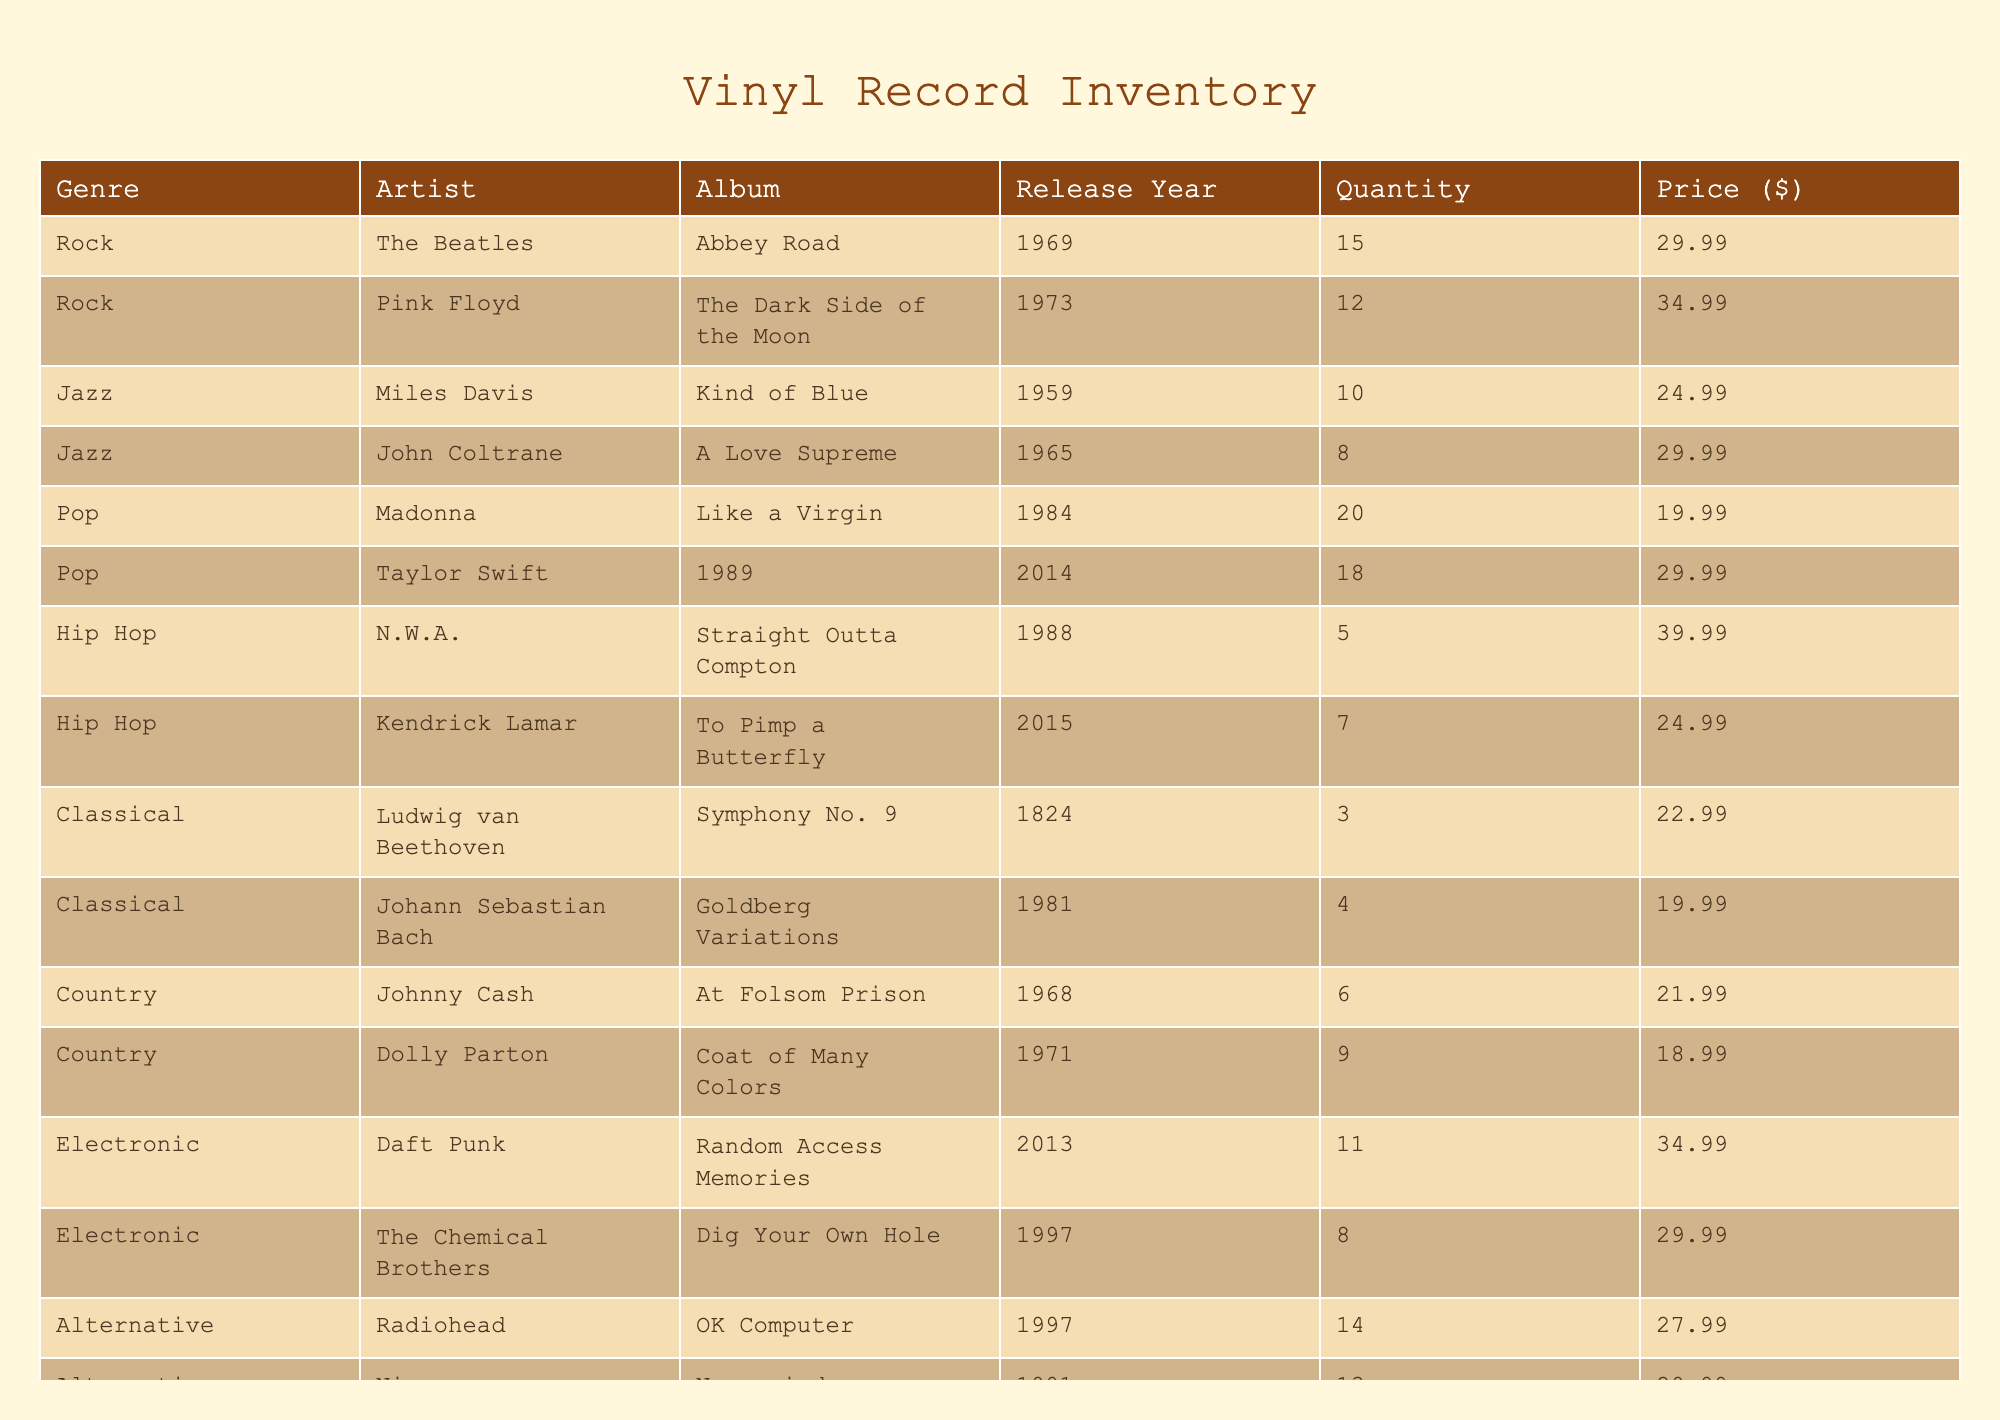What is the most expensive vinyl record in the inventory? The most expensive item can be found by comparing the prices listed for each album. The highest price is $39.99, which belongs to the album "Straight Outta Compton" by N.W.A.
Answer: $39.99 How many vinyl records are available in the Jazz genre? By referring to the Jazz entries, we find "Kind of Blue" with 10 copies and "A Love Supreme" with 8 copies. Adding them gives a total of 10 + 8 = 18.
Answer: 18 Which artist has the lowest quantity of vinyl records in the inventory? Reviewing the inventory, we see that Ludwig van Beethoven has 3 copies of "Symphony No. 9", which is the lowest quantity compared to all other artists listed.
Answer: 3 Is there any classical album from the 20th century in the inventory? Checking the classical albums, "Goldberg Variations" by Johann Sebastian Bach is from 1981, which is in the 20th century while "Symphony No. 9" is from 1824, so the answer is yes.
Answer: Yes What is the average price of vinyl records in the Country genre? The country genre has two records: "At Folsom Prison" priced at $21.99 and "Coat of Many Colors" priced at $18.99. The average price is calculated by (21.99 + 18.99) / 2 = 20.99.
Answer: 20.99 How many albums were released before the 1980s? We identify albums released before the 1980s: "Kind of Blue" (1959), "A Love Supreme" (1965), "Abbey Road" (1969), "At Folsom Prison" (1968), "Coat of Many Colors" (1971), "The Dark Side of the Moon" (1973), and "A Love Supreme" (1965). Counting them gives us 7 albums.
Answer: 7 Which genre has the highest total quantity of vinyl records in the inventory? By summing the quantities for each genre, we find: Rock 27, Jazz 18, Pop 38, Hip Hop 12, Classical 7, Country 15, Electronic 19, and Alternative 27. The genre with the highest quantity is Pop with 38.
Answer: Pop How many total vinyl records are available across all genres? To find the total, we sum the quantities of all records in the inventory: 15 + 12 + 10 + 8 + 20 + 18 + 5 + 7 + 3 + 4 + 6 + 9 + 11 + 8 + 14 + 13 =  100.
Answer: 100 